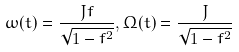Convert formula to latex. <formula><loc_0><loc_0><loc_500><loc_500>\omega ( t ) = \frac { J { f } } { \sqrt { 1 - f ^ { 2 } } } , \Omega ( t ) = \frac { J } { \sqrt { 1 - f ^ { 2 } } }</formula> 